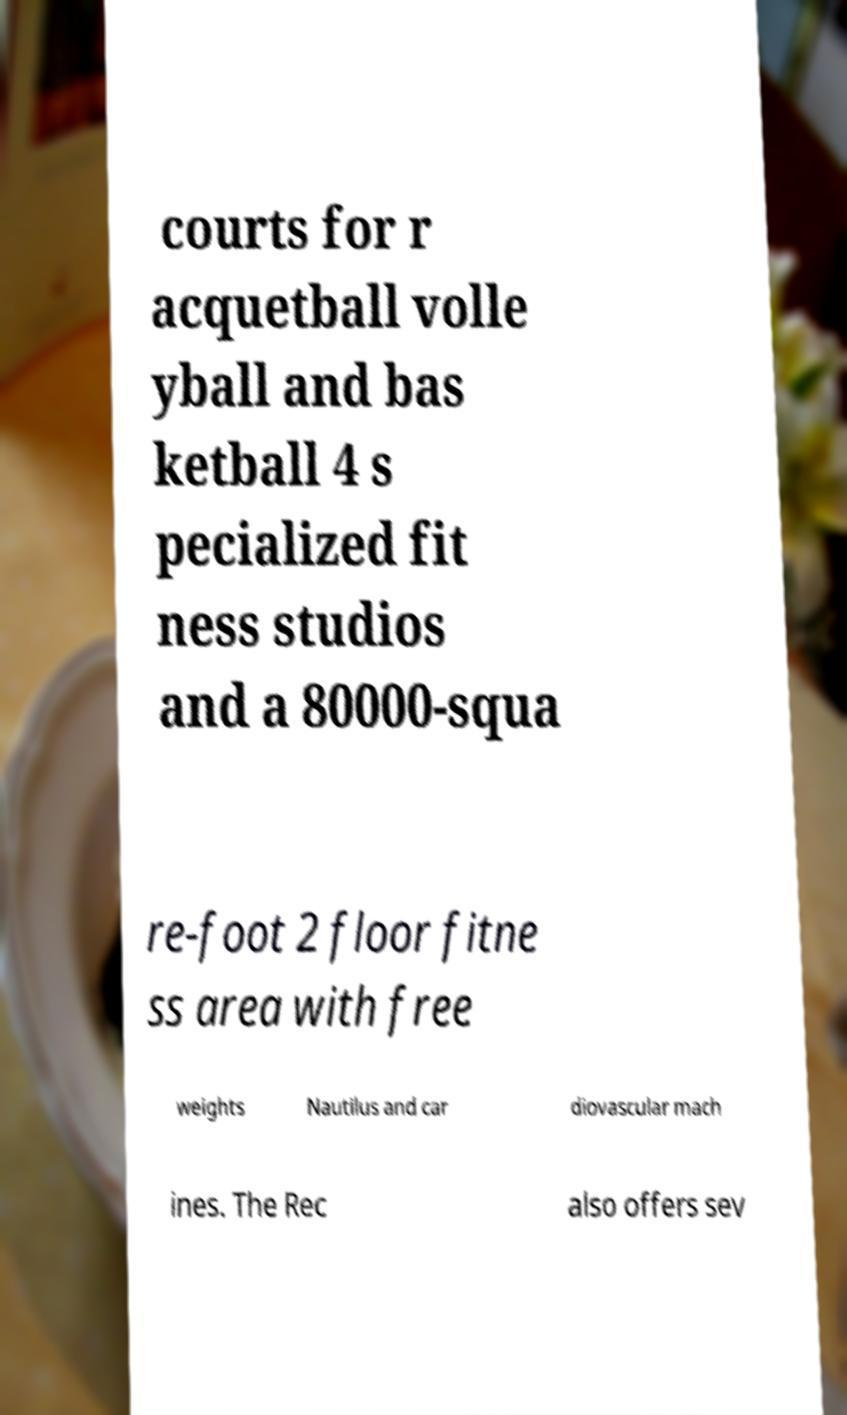Could you assist in decoding the text presented in this image and type it out clearly? courts for r acquetball volle yball and bas ketball 4 s pecialized fit ness studios and a 80000-squa re-foot 2 floor fitne ss area with free weights Nautilus and car diovascular mach ines. The Rec also offers sev 